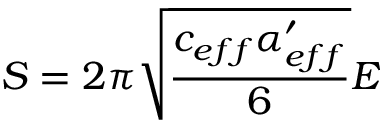<formula> <loc_0><loc_0><loc_500><loc_500>S = 2 \pi \sqrt { \frac { c _ { e f f } \alpha _ { e f f } ^ { \prime } } { 6 } } E</formula> 